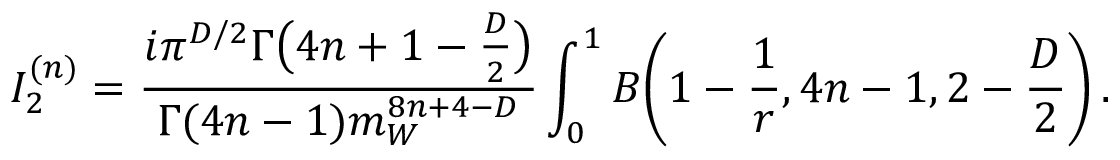<formula> <loc_0><loc_0><loc_500><loc_500>I _ { 2 } ^ { ( n ) } = \frac { i \pi ^ { D / 2 } \Gamma \left ( 4 n + 1 - \frac { D } { 2 } \right ) } { \Gamma ( 4 n - 1 ) m _ { W } ^ { 8 n + 4 - D } } \int _ { 0 } ^ { 1 } B \left ( 1 - \frac { 1 } { r } , 4 n - 1 , 2 - \frac { D } { 2 } \right ) \, .</formula> 